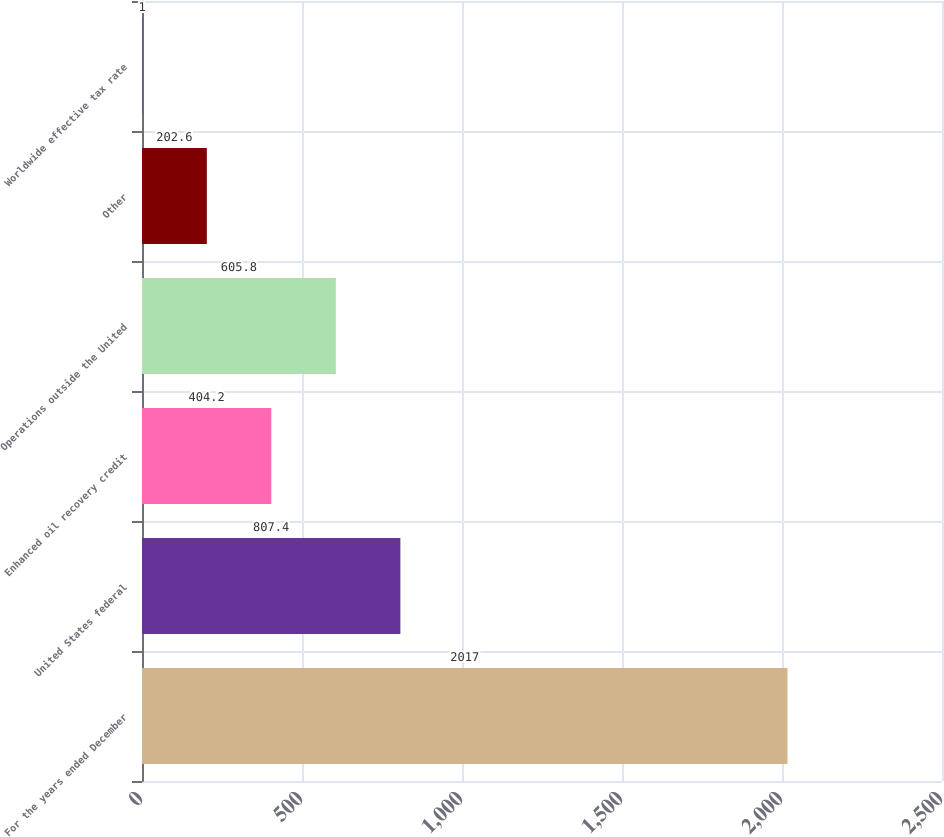<chart> <loc_0><loc_0><loc_500><loc_500><bar_chart><fcel>For the years ended December<fcel>United States federal<fcel>Enhanced oil recovery credit<fcel>Operations outside the United<fcel>Other<fcel>Worldwide effective tax rate<nl><fcel>2017<fcel>807.4<fcel>404.2<fcel>605.8<fcel>202.6<fcel>1<nl></chart> 